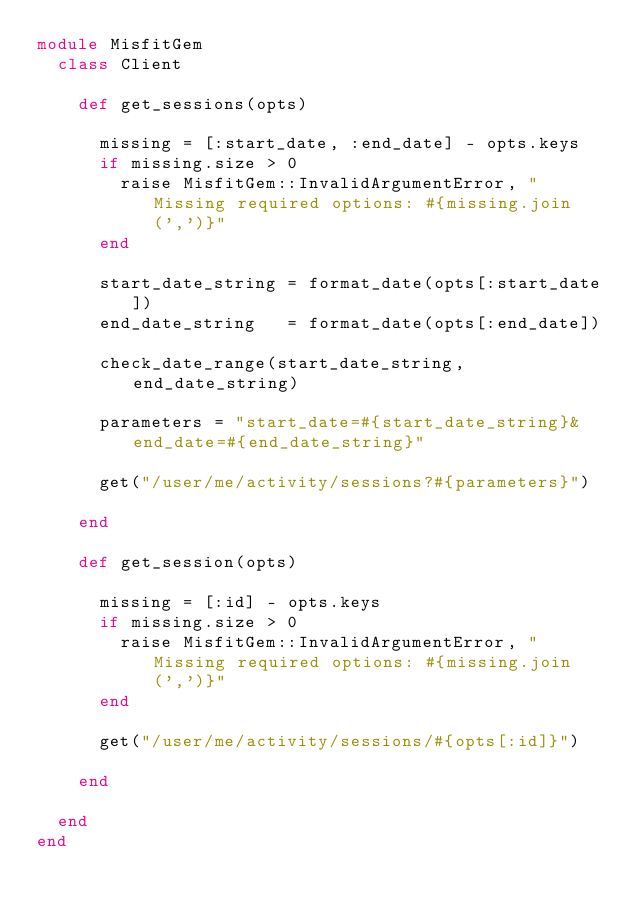<code> <loc_0><loc_0><loc_500><loc_500><_Ruby_>module MisfitGem
  class Client

    def get_sessions(opts)
      
      missing = [:start_date, :end_date] - opts.keys
      if missing.size > 0
        raise MisfitGem::InvalidArgumentError, "Missing required options: #{missing.join(',')}"
      end
      
      start_date_string = format_date(opts[:start_date])
      end_date_string   = format_date(opts[:end_date])
      
      check_date_range(start_date_string, end_date_string)
      
      parameters = "start_date=#{start_date_string}&end_date=#{end_date_string}"
            
      get("/user/me/activity/sessions?#{parameters}")
      
    end
    
    def get_session(opts)

      missing = [:id] - opts.keys
      if missing.size > 0
        raise MisfitGem::InvalidArgumentError, "Missing required options: #{missing.join(',')}"
      end

      get("/user/me/activity/sessions/#{opts[:id]}")

    end
    
  end
end
</code> 